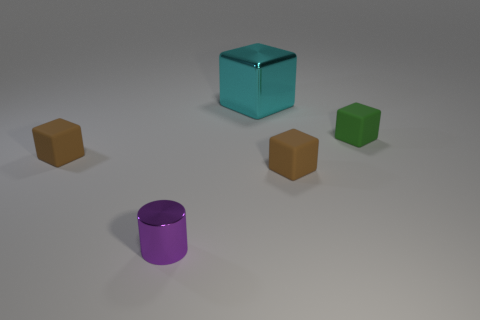There is a brown thing that is on the left side of the purple object; is it the same shape as the metal object that is in front of the metallic block?
Your answer should be very brief. No. There is a green block; how many green matte objects are to the right of it?
Offer a very short reply. 0. Is the brown block to the left of the purple metallic thing made of the same material as the large object?
Offer a very short reply. No. The shiny thing that is the same shape as the green rubber thing is what color?
Provide a succinct answer. Cyan. What is the shape of the green thing?
Keep it short and to the point. Cube. How many things are either large brown matte spheres or matte blocks?
Ensure brevity in your answer.  3. How many other things are there of the same shape as the tiny green matte thing?
Offer a very short reply. 3. Are any tiny cyan metallic things visible?
Offer a terse response. No. How many objects are green objects or small rubber cubes to the right of the small metal thing?
Ensure brevity in your answer.  2. Is the size of the brown rubber object left of the purple thing the same as the large cyan block?
Ensure brevity in your answer.  No. 